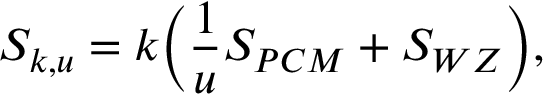<formula> <loc_0><loc_0><loc_500><loc_500>S _ { k , u } = k \left ( { \frac { 1 } { u } } S _ { P C M } + S _ { W Z } \right ) ,</formula> 